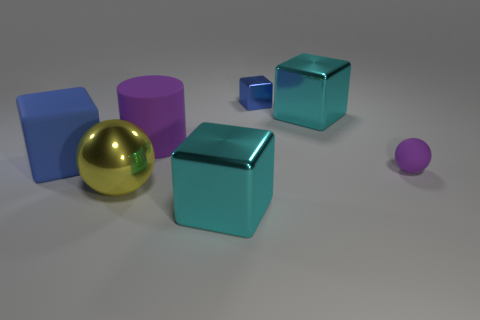How many purple objects are left of the purple matte sphere?
Ensure brevity in your answer.  1. Do the cyan object that is in front of the large purple matte cylinder and the large blue block have the same material?
Offer a terse response. No. What is the color of the big matte object that is the same shape as the small metal object?
Ensure brevity in your answer.  Blue. What is the shape of the tiny rubber object?
Your answer should be compact. Sphere. What number of objects are rubber cylinders or small rubber things?
Provide a short and direct response. 2. There is a large metal cube that is left of the small blue shiny thing; does it have the same color as the metallic cube to the right of the tiny blue metal thing?
Provide a succinct answer. Yes. How many other things are the same shape as the large purple object?
Your answer should be compact. 0. Are there any spheres?
Your response must be concise. Yes. How many things are tiny gray rubber spheres or matte things that are to the right of the tiny blue shiny thing?
Offer a very short reply. 1. There is a rubber sphere that is right of the metallic sphere; is it the same size as the large rubber block?
Offer a very short reply. No. 